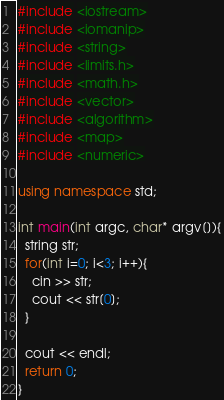Convert code to text. <code><loc_0><loc_0><loc_500><loc_500><_C++_>#include <iostream>
#include <iomanip>
#include <string>
#include <limits.h>
#include <math.h>
#include <vector>
#include <algorithm>
#include <map>
#include <numeric>

using namespace std;

int main(int argc, char* argv[]){
  string str;
  for(int i=0; i<3; i++){
    cin >> str;
    cout << str[0];
  }

  cout << endl;
  return 0;
}</code> 